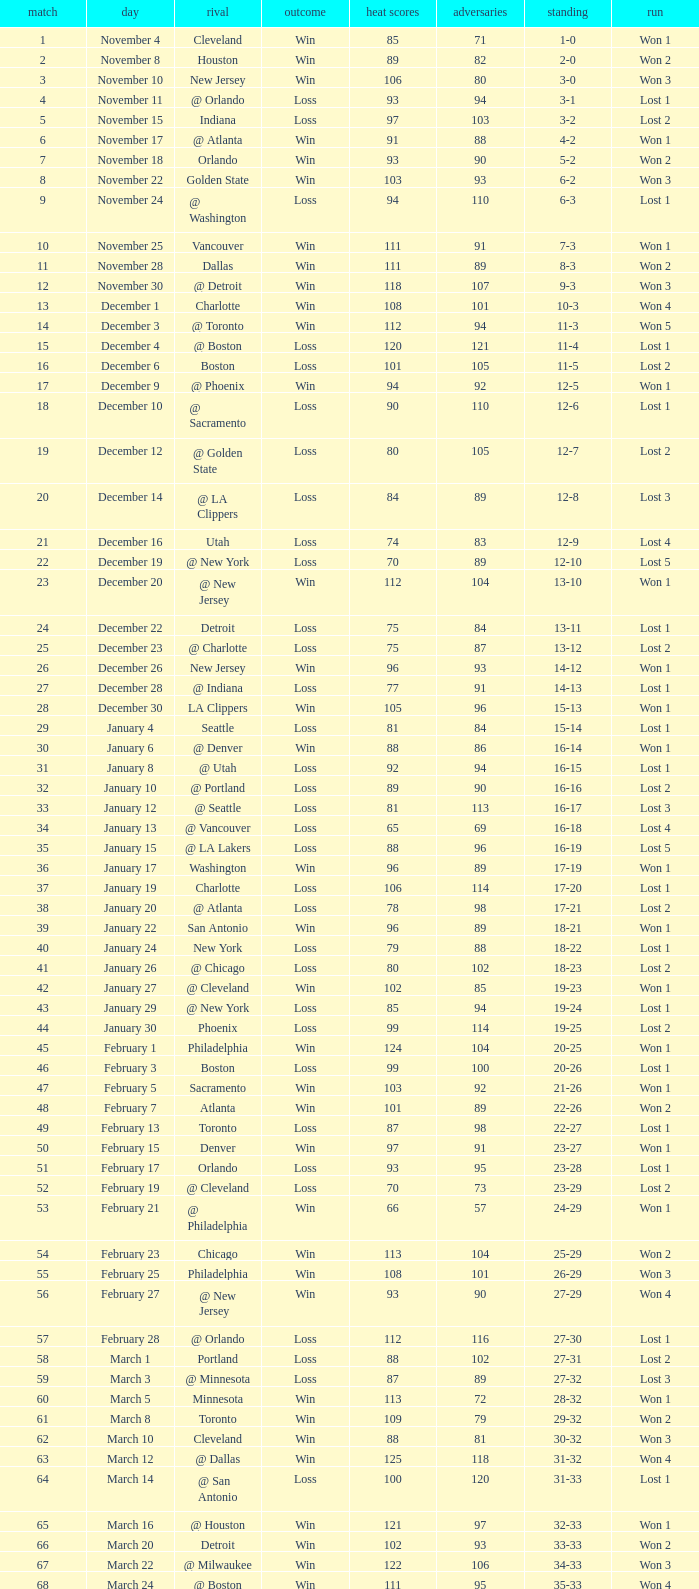What is the average Heat Points, when Result is "Loss", when Game is greater than 72, and when Date is "April 21"? 92.0. 